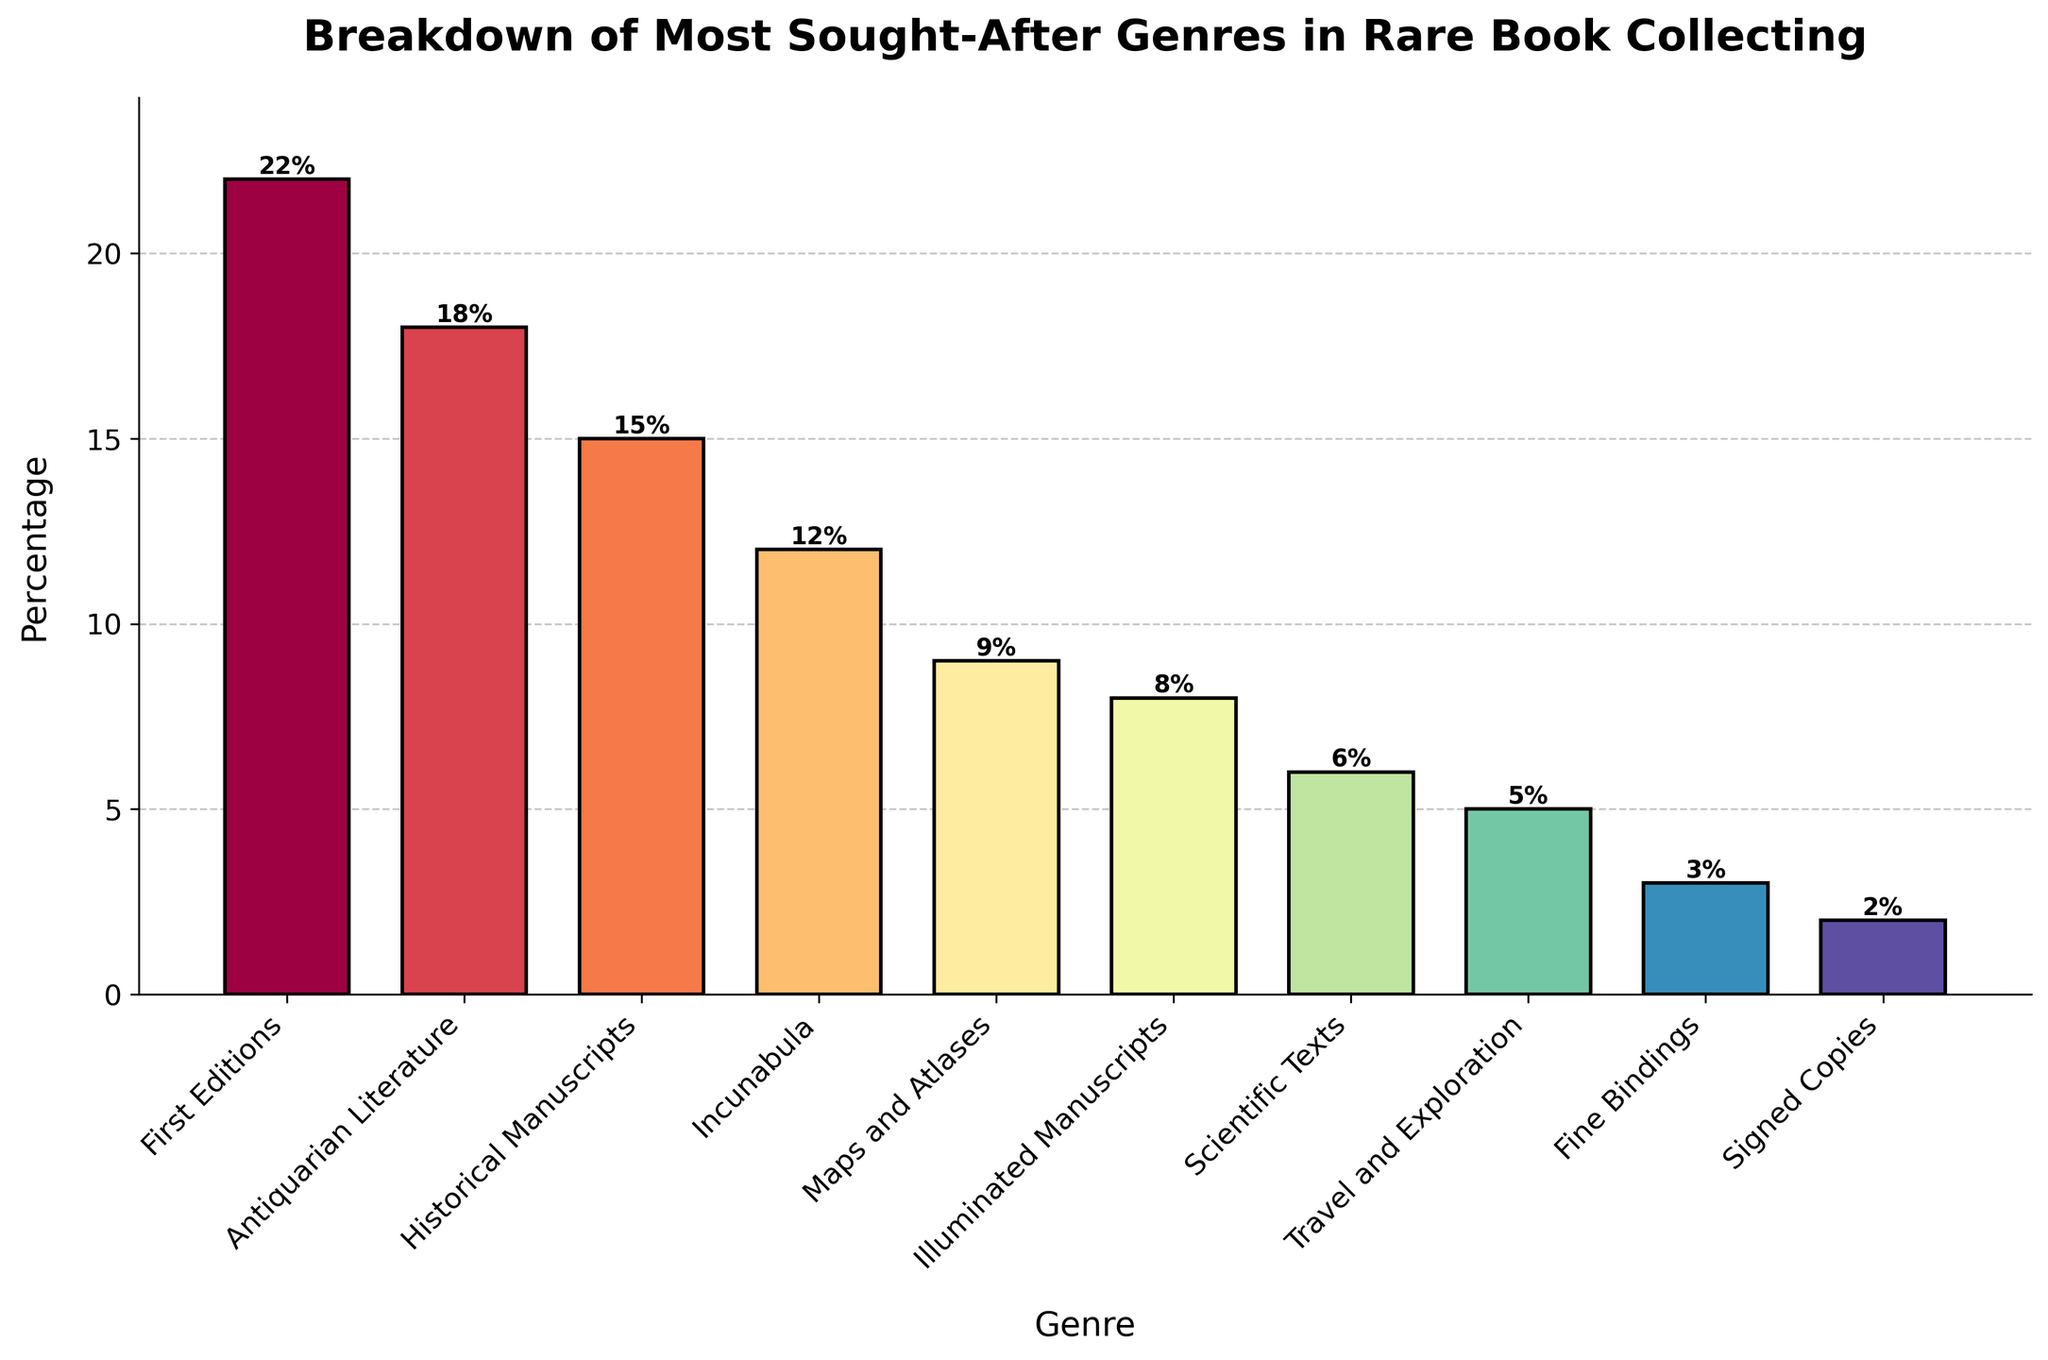Which genre has the highest percentage? The highest bar represents the genre with the highest percentage. The "First Editions" bar is the tallest.
Answer: First Editions Which two genres combined make up the majority of the chart? Add the percentages of the top two genres ("First Editions" at 22% and "Antiquarian Literature" at 18%). The total is 22% + 18% = 40%, which is above 50% of the chart.
Answer: First Editions and Antiquarian Literature What is the difference in percentage between "Scientific Texts" and "Travel and Exploration"? Subtract the percentage of "Travel and Exploration" (5%) from the percentage of "Scientific Texts" (6%). 6% - 5% = 1%
Answer: 1% How many genres have a percentage greater than or equal to 10%? Count the genres that have percentages greater than or equal to 10%. They are "First Editions" (22%), "Antiquarian Literature" (18%), "Historical Manuscripts" (15%), and "Incunabula" (12%). There are 4 such genres.
Answer: 4 Which genre has the smallest percentage? The shortest bar indicates the genre with the smallest percentage. The "Signed Copies" bar is the shortest.
Answer: Signed Copies What is the total percentage covered by genres below "Illuminated Manuscripts"? Sum the percentages of "Scientific Texts" (6%), "Travel and Exploration" (5%), "Fine Bindings" (3%), and "Signed Copies" (2%). The total is 6% + 5% + 3% + 2% = 16%
Answer: 16% How much more popular is "First Editions" compared to "Maps and Atlases"? Subtract the percentage of "Maps and Atlases" (9%) from "First Editions" (22%). 22% - 9% = 13%
Answer: 13% What is the sum of the percentages of all genres above 5%? Add the percentages of "First Editions" (22%), "Antiquarian Literature" (18%), "Historical Manuscripts" (15%), "Incunabula" (12%), "Maps and Atlases" (9%), and "Illuminated Manuscripts" (8%). The total is 22% + 18% + 15% + 12% + 9% + 8% = 84%
Answer: 84% Between "Maps and Atlases" and "Scientific Texts", which genre is more popular and by how much? Compare the percentages of "Maps and Atlases" (9%) and "Scientific Texts" (6%). Subtract the smaller percentage from the larger. 9% - 6% = 3%
Answer: Maps and Atlases by 3% 